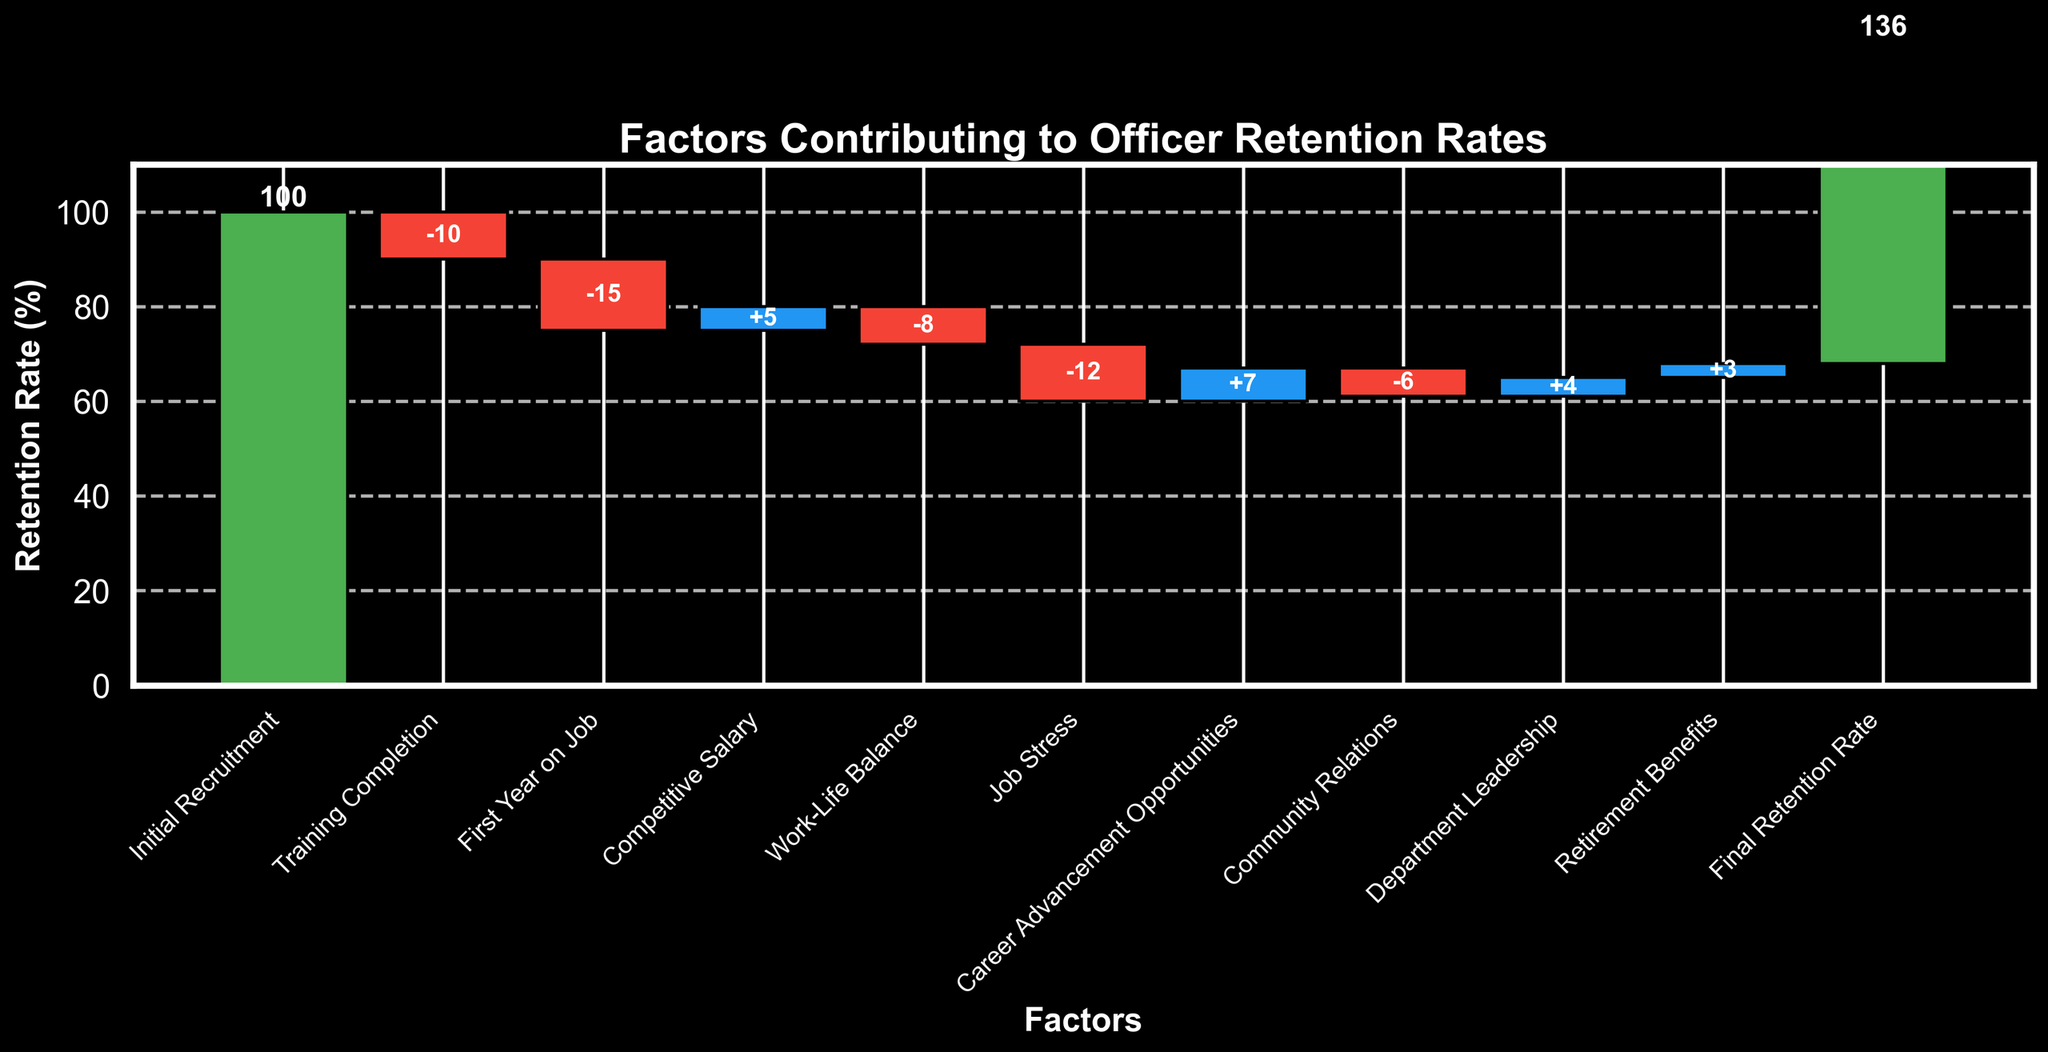What's the title of the chart? The title is typically located at the top of the chart and provides an overview of what the chart is about. In this case, it tells us that the chart is about the factors contributing to officer retention rates.
Answer: Factors Contributing to Officer Retention Rates What is the retention rate after the first year on the job? From the chart, after the first year on the job, there's a significant decline. The initial recruitment starts at 100%, and the retention rate decreases by 15%, leading to a remaining retention rate of 85%.
Answer: 85% By how much does job stress affect the retention rate? The negative effect of job stress on officer retention is indicated by the red bar labeled "Job Stress." The value is -12, which means job stress decreases the retention rate by 12 percentage points.
Answer: -12 Which factor contributes positively the most to officer retention? In the waterfall chart, the largest positive change can be identified by the tallest blue bar. The bar labeled "Career Advancement Opportunities" has the value +7, which is the highest positive value among the factors.
Answer: Career Advancement Opportunities How does work-life balance affect the retention rate compared to competitive salary? Competitive salary has a positive effect of +5, while work-life balance has a negative effect of -8. Comparing these, work-life balance negatively affects retention more than competitive salary positively affects it.
Answer: Work-life balance affects more negatively What is the final retention rate after accounting for all factors? The final retention rate is depicted at the last point of the chart and is also explicitly mentioned in the data. It is 68%.
Answer: 68% Which factors positively influence the retention rate? The positive influences can be identified by the blue bars in the waterfall chart. These include "Competitive Salary" (+5), "Career Advancement Opportunities" (+7), "Department Leadership" (+4), and "Retirement Benefits" (+3).
Answer: Competitive Salary, Career Advancement Opportunities, Department Leadership, Retirement Benefits What is the cumulative decline in retention rate due to negative factors? Summing up the values of all negative factors: Training Completion (-10), First Year on Job (-15), Work-Life Balance (-8), Job Stress (-12), and Community Relations (-6). The cumulative negative impact is -51.
Answer: -51 